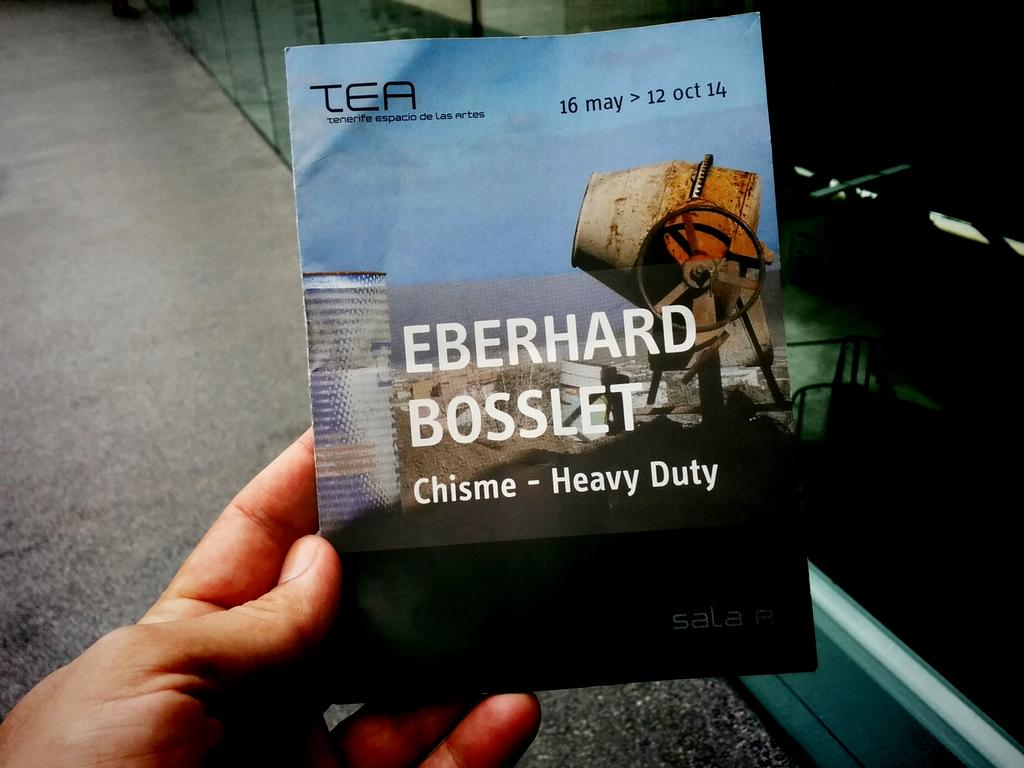What is the publication about?
Offer a very short reply. Unanswerable. What year is this published?
Keep it short and to the point. 2014. 